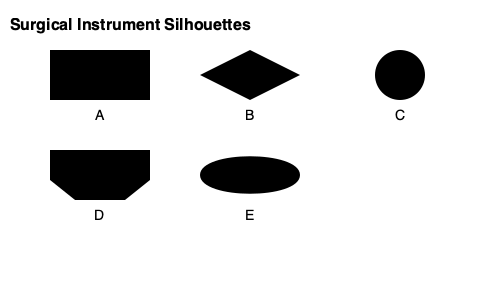Which silhouette best represents the end effector of a da Vinci surgical robot's EndoWrist instrument designed for grasping and manipulating tissue during minimally invasive procedures? To identify the correct silhouette for the da Vinci surgical robot's EndoWrist instrument, let's analyze each option:

1. Silhouette A: Rectangular shape - This is too simplistic and doesn't represent the articulation capabilities of an EndoWrist instrument.

2. Silhouette B: Diamond shape - This doesn't accurately represent any common surgical instrument end effector.

3. Silhouette C: Circular shape - This could represent a camera or lens, but not a grasping instrument.

4. Silhouette D: Trapezoidal shape with a split end - This most closely resembles the end effector of an EndoWrist instrument. The split end represents the jaws of the grasper, which can open and close to manipulate tissue. The trapezoidal shape indicates the articulation mechanism that allows for precise movements.

5. Silhouette E: Curved shape - This could represent a retractor or a blunt dissector, but not a grasping instrument.

The EndoWrist instruments are designed to mimic the movements of the human wrist, providing seven degrees of freedom for enhanced dexterity during minimally invasive procedures. The grasping end effector is a crucial component for manipulating tissue, and its design typically includes two articulating jaws that can open and close.

Given these characteristics, silhouette D best represents the end effector of a da Vinci surgical robot's EndoWrist instrument designed for grasping and manipulating tissue.
Answer: D 